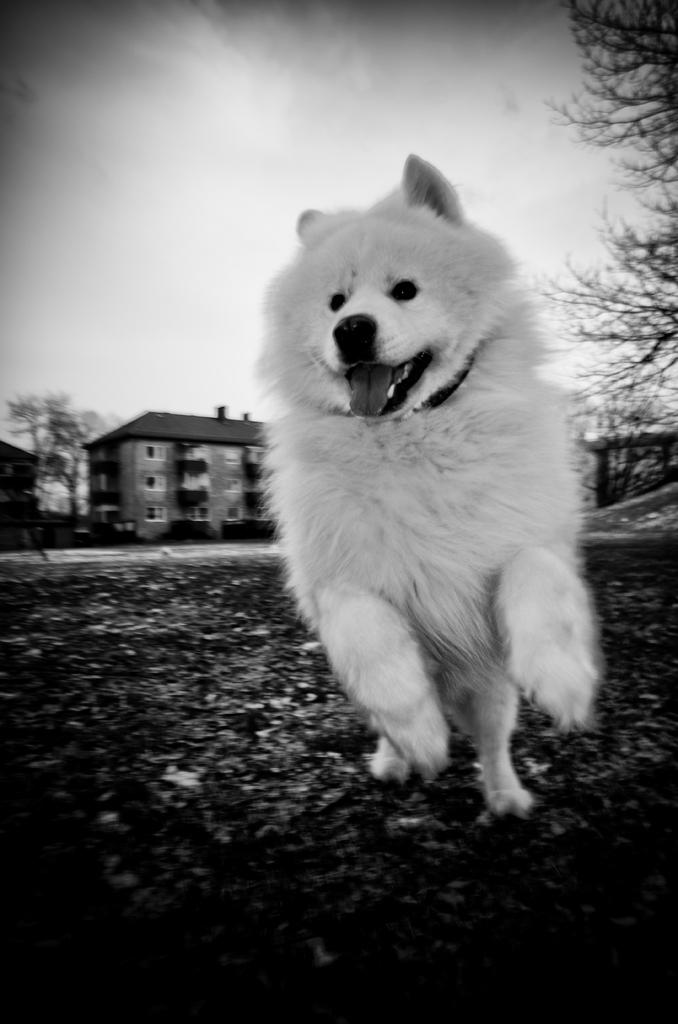What animal can be seen in the picture? There is a dog in the picture. What is the dog doing in the picture? The dog is running. What can be seen in the background of the picture? There are trees in the background of the picture. What is the condition of the sky in the picture? The sky is clear in the picture. How many chairs are placed around the faucet in the image? There is no faucet or chairs present in the image; it features a dog running with trees in the background and a clear sky. 